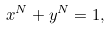Convert formula to latex. <formula><loc_0><loc_0><loc_500><loc_500>x ^ { N } + y ^ { N } = 1 ,</formula> 